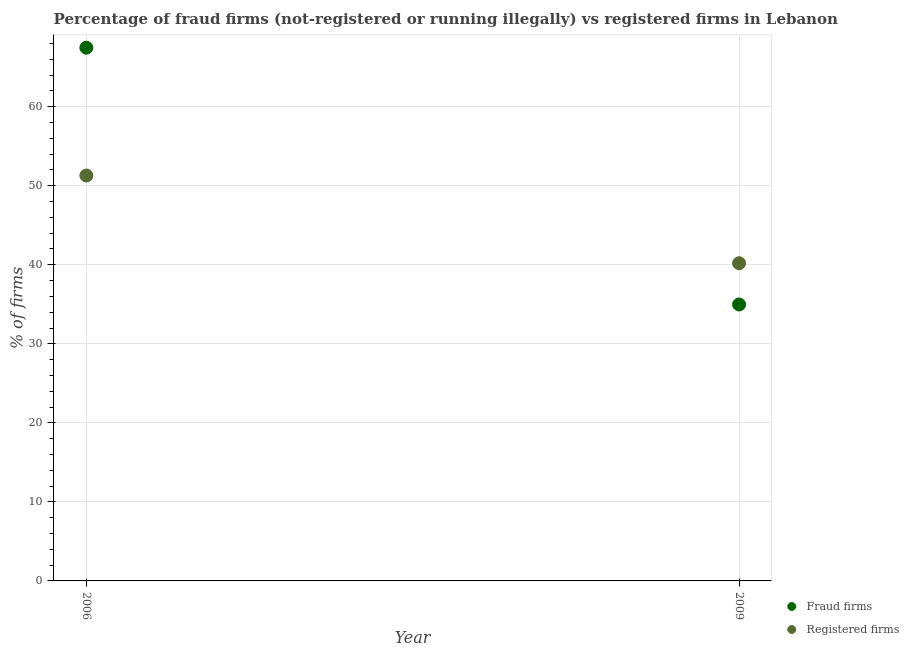How many different coloured dotlines are there?
Make the answer very short. 2. What is the percentage of registered firms in 2006?
Provide a succinct answer. 51.3. Across all years, what is the maximum percentage of fraud firms?
Offer a terse response. 67.47. Across all years, what is the minimum percentage of fraud firms?
Make the answer very short. 34.98. In which year was the percentage of fraud firms maximum?
Offer a very short reply. 2006. What is the total percentage of registered firms in the graph?
Offer a very short reply. 91.5. What is the difference between the percentage of registered firms in 2006 and that in 2009?
Make the answer very short. 11.1. What is the difference between the percentage of fraud firms in 2006 and the percentage of registered firms in 2009?
Make the answer very short. 27.27. What is the average percentage of fraud firms per year?
Your answer should be compact. 51.22. In the year 2006, what is the difference between the percentage of registered firms and percentage of fraud firms?
Keep it short and to the point. -16.17. In how many years, is the percentage of fraud firms greater than 20 %?
Give a very brief answer. 2. What is the ratio of the percentage of registered firms in 2006 to that in 2009?
Ensure brevity in your answer.  1.28. Is the percentage of registered firms in 2006 less than that in 2009?
Your response must be concise. No. In how many years, is the percentage of registered firms greater than the average percentage of registered firms taken over all years?
Offer a terse response. 1. Is the percentage of registered firms strictly greater than the percentage of fraud firms over the years?
Give a very brief answer. No. What is the difference between two consecutive major ticks on the Y-axis?
Offer a very short reply. 10. Where does the legend appear in the graph?
Your answer should be compact. Bottom right. How many legend labels are there?
Ensure brevity in your answer.  2. How are the legend labels stacked?
Keep it short and to the point. Vertical. What is the title of the graph?
Your answer should be compact. Percentage of fraud firms (not-registered or running illegally) vs registered firms in Lebanon. Does "Female population" appear as one of the legend labels in the graph?
Your response must be concise. No. What is the label or title of the X-axis?
Offer a terse response. Year. What is the label or title of the Y-axis?
Make the answer very short. % of firms. What is the % of firms of Fraud firms in 2006?
Your response must be concise. 67.47. What is the % of firms of Registered firms in 2006?
Keep it short and to the point. 51.3. What is the % of firms in Fraud firms in 2009?
Ensure brevity in your answer.  34.98. What is the % of firms in Registered firms in 2009?
Offer a very short reply. 40.2. Across all years, what is the maximum % of firms in Fraud firms?
Offer a very short reply. 67.47. Across all years, what is the maximum % of firms in Registered firms?
Provide a succinct answer. 51.3. Across all years, what is the minimum % of firms in Fraud firms?
Your response must be concise. 34.98. Across all years, what is the minimum % of firms in Registered firms?
Provide a short and direct response. 40.2. What is the total % of firms of Fraud firms in the graph?
Keep it short and to the point. 102.45. What is the total % of firms in Registered firms in the graph?
Provide a succinct answer. 91.5. What is the difference between the % of firms in Fraud firms in 2006 and that in 2009?
Keep it short and to the point. 32.49. What is the difference between the % of firms in Registered firms in 2006 and that in 2009?
Keep it short and to the point. 11.1. What is the difference between the % of firms in Fraud firms in 2006 and the % of firms in Registered firms in 2009?
Give a very brief answer. 27.27. What is the average % of firms in Fraud firms per year?
Provide a succinct answer. 51.23. What is the average % of firms of Registered firms per year?
Give a very brief answer. 45.75. In the year 2006, what is the difference between the % of firms of Fraud firms and % of firms of Registered firms?
Provide a short and direct response. 16.17. In the year 2009, what is the difference between the % of firms of Fraud firms and % of firms of Registered firms?
Your answer should be compact. -5.22. What is the ratio of the % of firms in Fraud firms in 2006 to that in 2009?
Your response must be concise. 1.93. What is the ratio of the % of firms in Registered firms in 2006 to that in 2009?
Your response must be concise. 1.28. What is the difference between the highest and the second highest % of firms of Fraud firms?
Offer a terse response. 32.49. What is the difference between the highest and the lowest % of firms of Fraud firms?
Ensure brevity in your answer.  32.49. 